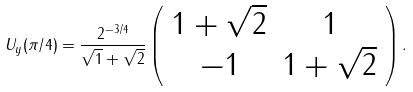Convert formula to latex. <formula><loc_0><loc_0><loc_500><loc_500>U _ { y } ( \pi / 4 ) = \frac { 2 ^ { - 3 / 4 } } { \sqrt { 1 } + \sqrt { 2 } } \left ( \begin{array} { c c } 1 + \sqrt { 2 } & 1 \\ - 1 & 1 + \sqrt { 2 } \end{array} \right ) .</formula> 